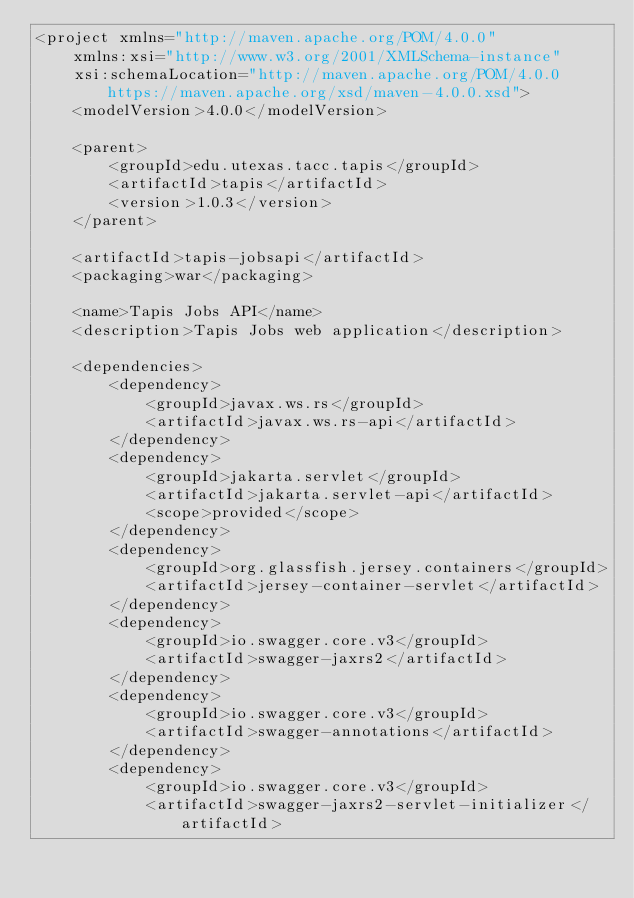Convert code to text. <code><loc_0><loc_0><loc_500><loc_500><_XML_><project xmlns="http://maven.apache.org/POM/4.0.0"
	xmlns:xsi="http://www.w3.org/2001/XMLSchema-instance"
	xsi:schemaLocation="http://maven.apache.org/POM/4.0.0 https://maven.apache.org/xsd/maven-4.0.0.xsd">
	<modelVersion>4.0.0</modelVersion>
	
	<parent>
		<groupId>edu.utexas.tacc.tapis</groupId>
		<artifactId>tapis</artifactId>
		<version>1.0.3</version>
	</parent>
	
	<artifactId>tapis-jobsapi</artifactId>
	<packaging>war</packaging>
	
	<name>Tapis Jobs API</name>
	<description>Tapis Jobs web application</description>

    <dependencies>
        <dependency>
            <groupId>javax.ws.rs</groupId>
            <artifactId>javax.ws.rs-api</artifactId>
        </dependency>
        <dependency>
            <groupId>jakarta.servlet</groupId>
            <artifactId>jakarta.servlet-api</artifactId>
            <scope>provided</scope>
        </dependency>
        <dependency>
            <groupId>org.glassfish.jersey.containers</groupId>
            <artifactId>jersey-container-servlet</artifactId>
        </dependency>
        <dependency>
            <groupId>io.swagger.core.v3</groupId>
            <artifactId>swagger-jaxrs2</artifactId>
        </dependency>
        <dependency>
            <groupId>io.swagger.core.v3</groupId>
            <artifactId>swagger-annotations</artifactId>
        </dependency>
        <dependency>
            <groupId>io.swagger.core.v3</groupId>
            <artifactId>swagger-jaxrs2-servlet-initializer</artifactId></code> 